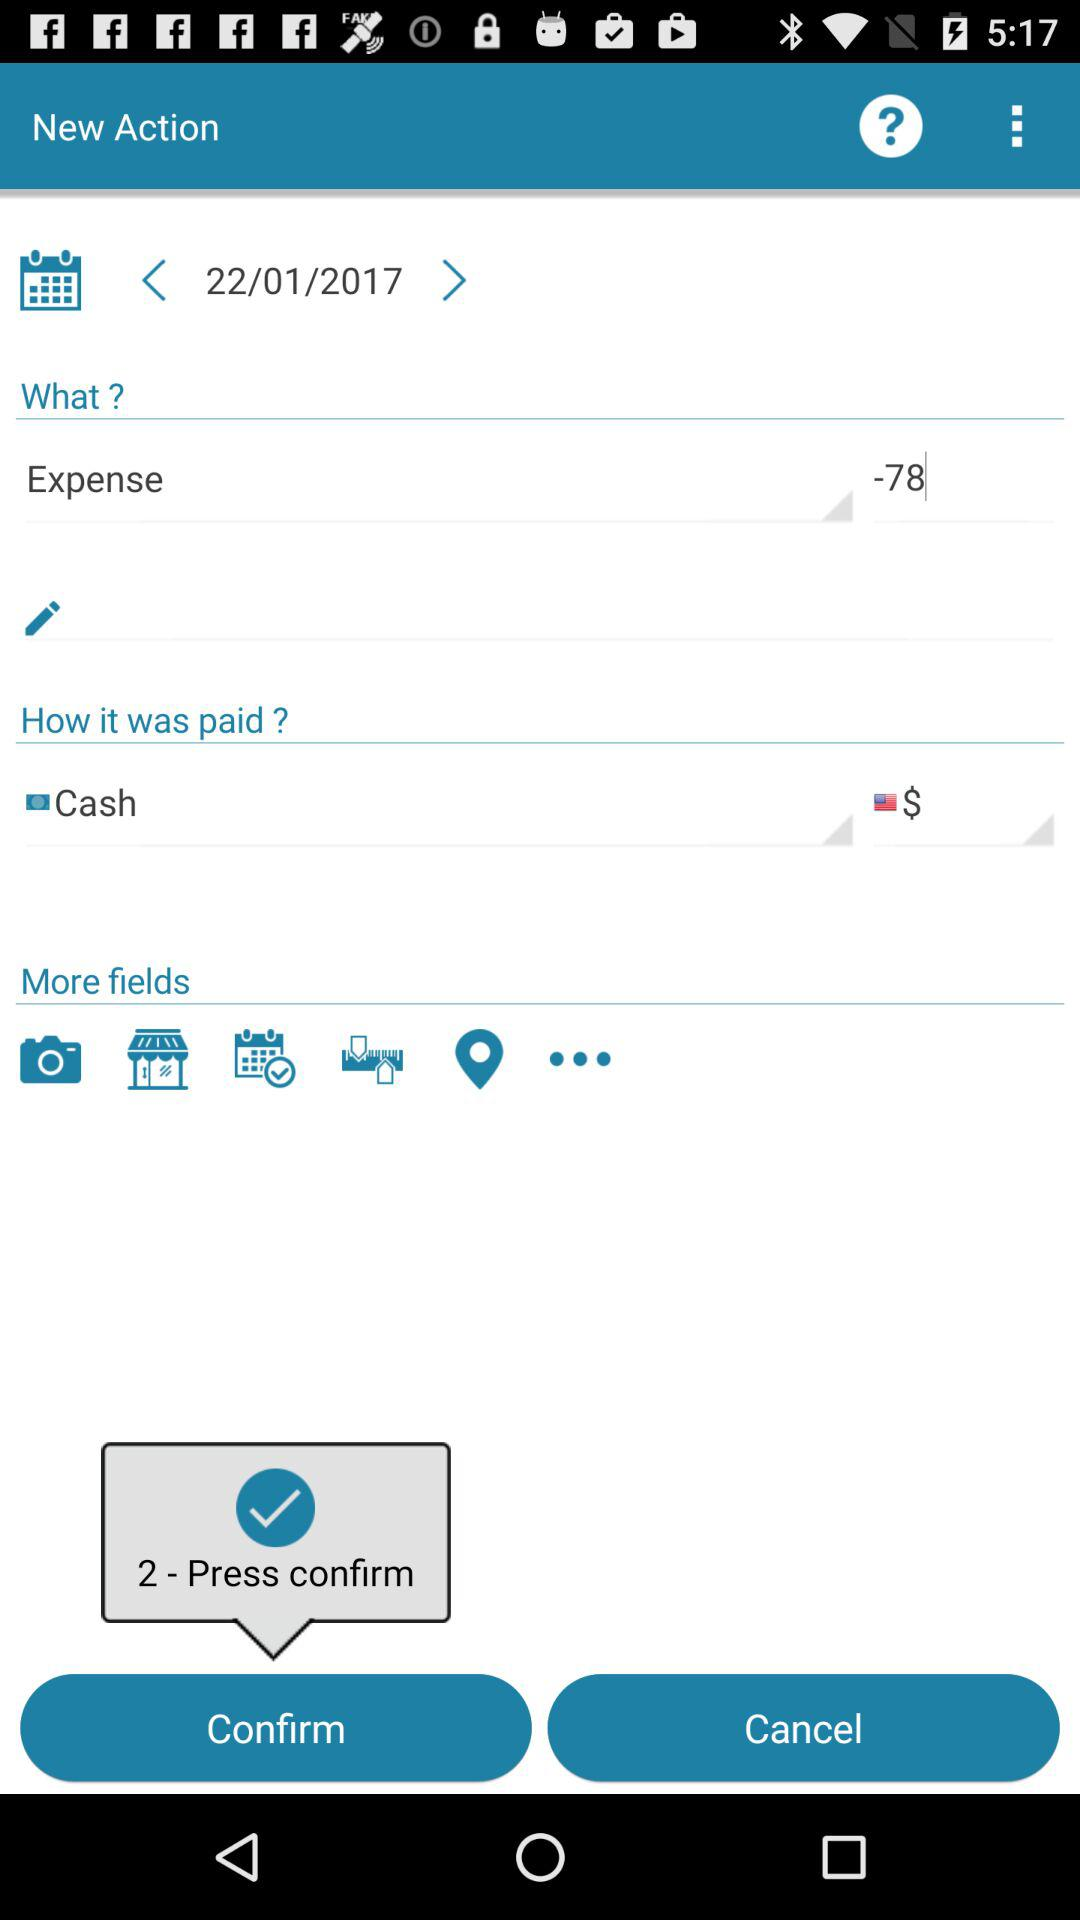What is the date of the expense?
Answer the question using a single word or phrase. 22/01/2017 